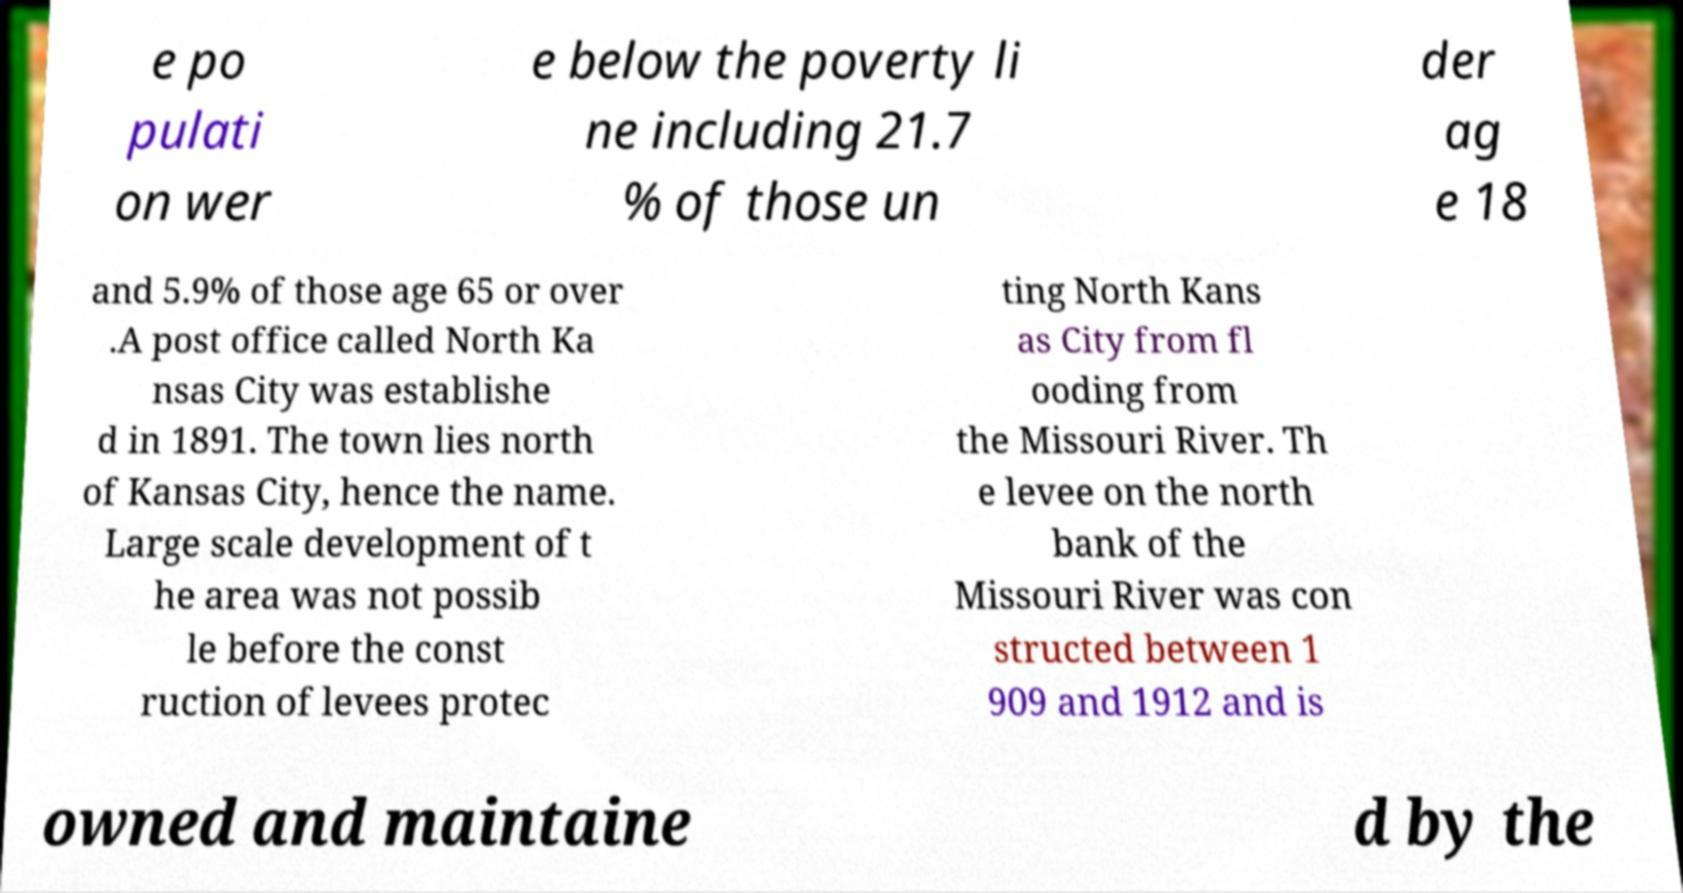There's text embedded in this image that I need extracted. Can you transcribe it verbatim? e po pulati on wer e below the poverty li ne including 21.7 % of those un der ag e 18 and 5.9% of those age 65 or over .A post office called North Ka nsas City was establishe d in 1891. The town lies north of Kansas City, hence the name. Large scale development of t he area was not possib le before the const ruction of levees protec ting North Kans as City from fl ooding from the Missouri River. Th e levee on the north bank of the Missouri River was con structed between 1 909 and 1912 and is owned and maintaine d by the 